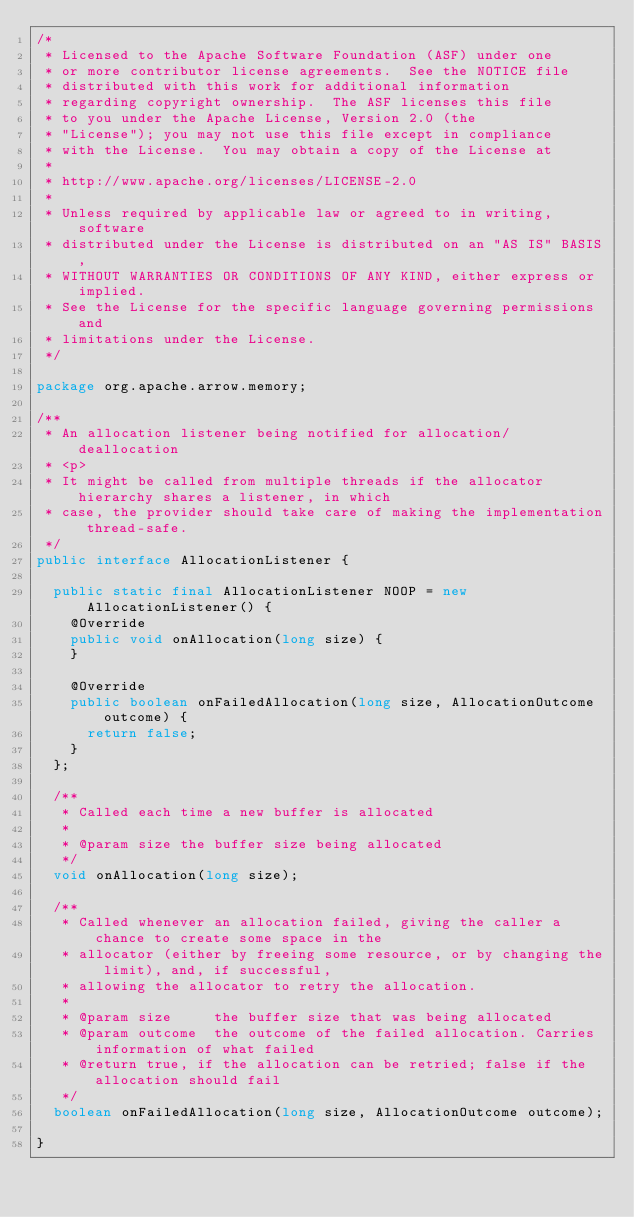<code> <loc_0><loc_0><loc_500><loc_500><_Java_>/*
 * Licensed to the Apache Software Foundation (ASF) under one
 * or more contributor license agreements.  See the NOTICE file
 * distributed with this work for additional information
 * regarding copyright ownership.  The ASF licenses this file
 * to you under the Apache License, Version 2.0 (the
 * "License"); you may not use this file except in compliance
 * with the License.  You may obtain a copy of the License at
 *
 * http://www.apache.org/licenses/LICENSE-2.0
 *
 * Unless required by applicable law or agreed to in writing, software
 * distributed under the License is distributed on an "AS IS" BASIS,
 * WITHOUT WARRANTIES OR CONDITIONS OF ANY KIND, either express or implied.
 * See the License for the specific language governing permissions and
 * limitations under the License.
 */

package org.apache.arrow.memory;

/**
 * An allocation listener being notified for allocation/deallocation
 * <p>
 * It might be called from multiple threads if the allocator hierarchy shares a listener, in which
 * case, the provider should take care of making the implementation thread-safe.
 */
public interface AllocationListener {

  public static final AllocationListener NOOP = new AllocationListener() {
    @Override
    public void onAllocation(long size) {
    }

    @Override
    public boolean onFailedAllocation(long size, AllocationOutcome outcome) {
      return false;
    }
  };

  /**
   * Called each time a new buffer is allocated
   *
   * @param size the buffer size being allocated
   */
  void onAllocation(long size);

  /**
   * Called whenever an allocation failed, giving the caller a chance to create some space in the
   * allocator (either by freeing some resource, or by changing the limit), and, if successful,
   * allowing the allocator to retry the allocation.
   *
   * @param size     the buffer size that was being allocated
   * @param outcome  the outcome of the failed allocation. Carries information of what failed
   * @return true, if the allocation can be retried; false if the allocation should fail
   */
  boolean onFailedAllocation(long size, AllocationOutcome outcome);

}
</code> 